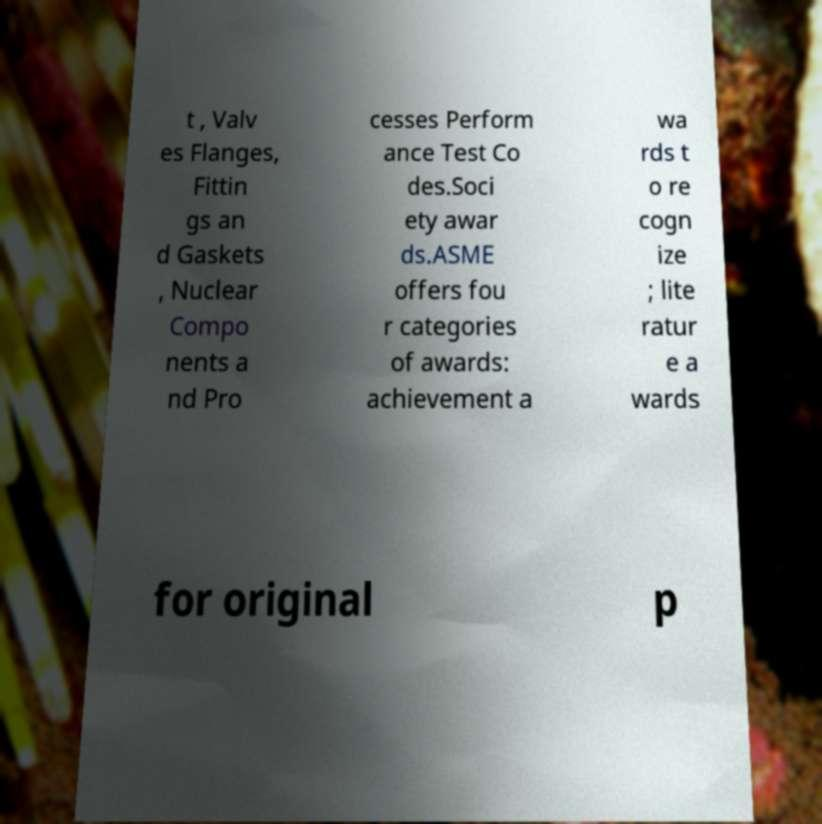Can you read and provide the text displayed in the image?This photo seems to have some interesting text. Can you extract and type it out for me? t , Valv es Flanges, Fittin gs an d Gaskets , Nuclear Compo nents a nd Pro cesses Perform ance Test Co des.Soci ety awar ds.ASME offers fou r categories of awards: achievement a wa rds t o re cogn ize ; lite ratur e a wards for original p 